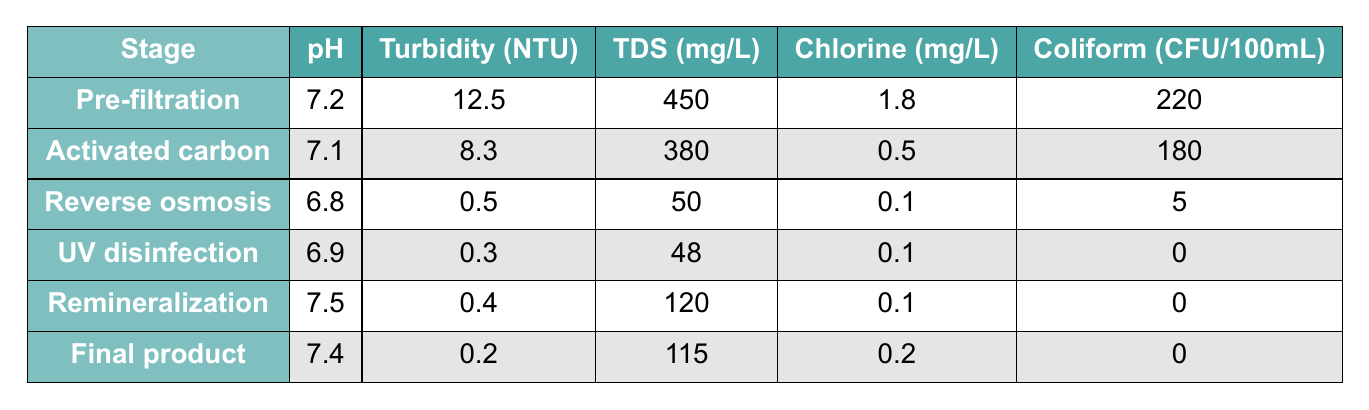What is the pH level after the reverse osmosis stage? The pH level for the reverse osmosis stage is provided in the table and specifically listed as 6.8.
Answer: 6.8 What is the turbidity of the final product? The turbidity value for the final product stage can be directly found in the table, which shows it to be 0.2 NTU.
Answer: 0.2 NTU How much total dissolved solids (TDS) are present in the pre-filtration stage? The table indicates that the total dissolved solids in the pre-filtration stage is 450 mg/L.
Answer: 450 mg/L Is there any coliform presence in the final product? The coliform value for the final product is 0 CFU/100mL, indicating no presence of coliform.
Answer: Yes What is the average pH of the water after the remineralization and final product stages? The average pH is calculated by summing the pH values (7.5 for remineralization and 7.4 for the final product) and dividing by 2: (7.5 + 7.4) / 2 = 7.45.
Answer: 7.45 How does the chlorine level change from the activated carbon to the UV disinfection stage? The chlorine level decreases from 0.5 mg/L in the activated carbon stage to 0.1 mg/L in the UV disinfection stage, indicating a reduction of 0.4 mg/L.
Answer: Decreases by 0.4 mg/L Which stage has the lowest turbidity, and what is its value? By examining the turbidity values across all stages, the UV disinfection stage has the lowest turbidity at 0.3 NTU.
Answer: UV disinfection, 0.3 NTU In which stage does coliform presence decrease to zero? The coliform value decreases to zero in both the UV disinfection and final product stages as detailed in the table where both report 0 CFU/100mL.
Answer: UV disinfection and final product stages What is the difference in total dissolved solids (TDS) between the pre-filtration and reverse osmosis stages? To find the difference in TDS, subtract the reverse osmosis TDS (50 mg/L) from pre-filtration TDS (450 mg/L): 450 - 50 = 400 mg/L.
Answer: 400 mg/L Which filtration stage shows the greatest reduction in coliform levels? The pre-filtration stage starts with 220 CFU/100mL and reduces to 0 in both UV disinfection and final product stages, showing a reduction of 220 CFU/100mL.
Answer: Pre-filtration stage, reduction of 220 CFU/100mL 